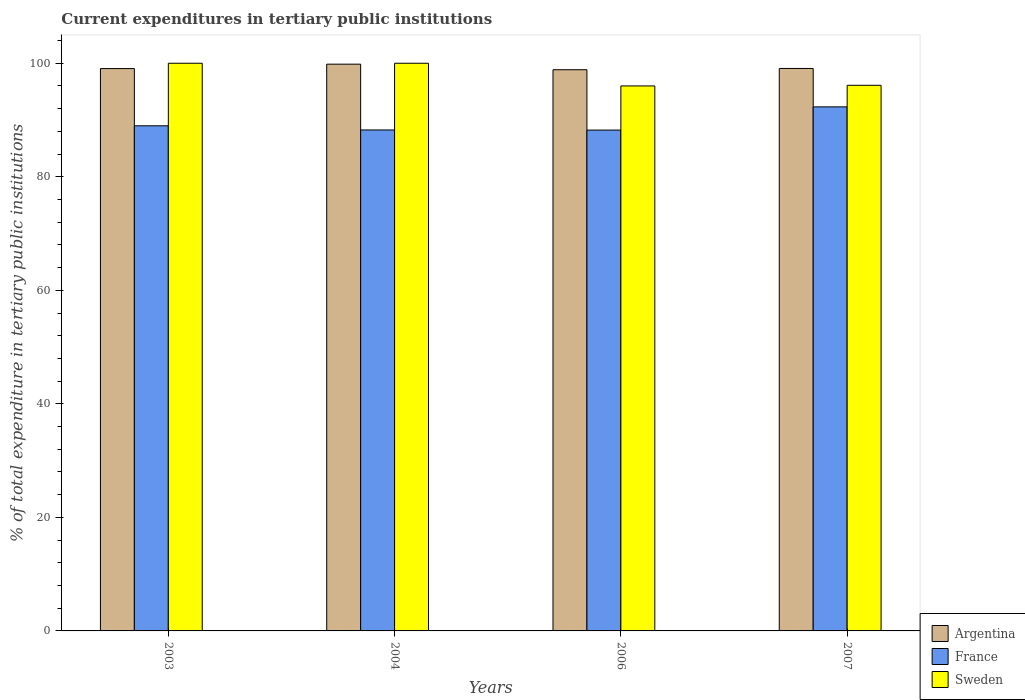How many different coloured bars are there?
Your response must be concise. 3. How many groups of bars are there?
Provide a succinct answer. 4. Are the number of bars per tick equal to the number of legend labels?
Keep it short and to the point. Yes. Are the number of bars on each tick of the X-axis equal?
Make the answer very short. Yes. What is the label of the 4th group of bars from the left?
Your answer should be compact. 2007. What is the current expenditures in tertiary public institutions in France in 2003?
Your answer should be compact. 88.98. Across all years, what is the maximum current expenditures in tertiary public institutions in France?
Your answer should be very brief. 92.32. Across all years, what is the minimum current expenditures in tertiary public institutions in Argentina?
Offer a terse response. 98.86. In which year was the current expenditures in tertiary public institutions in Sweden minimum?
Offer a very short reply. 2006. What is the total current expenditures in tertiary public institutions in France in the graph?
Your answer should be compact. 357.78. What is the difference between the current expenditures in tertiary public institutions in France in 2003 and that in 2004?
Offer a terse response. 0.73. What is the difference between the current expenditures in tertiary public institutions in Sweden in 2007 and the current expenditures in tertiary public institutions in Argentina in 2003?
Your response must be concise. -2.94. What is the average current expenditures in tertiary public institutions in Argentina per year?
Offer a very short reply. 99.21. In the year 2006, what is the difference between the current expenditures in tertiary public institutions in Sweden and current expenditures in tertiary public institutions in France?
Offer a terse response. 7.78. In how many years, is the current expenditures in tertiary public institutions in Argentina greater than 64 %?
Keep it short and to the point. 4. What is the ratio of the current expenditures in tertiary public institutions in Argentina in 2003 to that in 2007?
Make the answer very short. 1. Is the difference between the current expenditures in tertiary public institutions in Sweden in 2003 and 2004 greater than the difference between the current expenditures in tertiary public institutions in France in 2003 and 2004?
Ensure brevity in your answer.  No. What is the difference between the highest and the second highest current expenditures in tertiary public institutions in Argentina?
Give a very brief answer. 0.76. What is the difference between the highest and the lowest current expenditures in tertiary public institutions in France?
Provide a short and direct response. 4.09. What does the 1st bar from the right in 2003 represents?
Give a very brief answer. Sweden. Is it the case that in every year, the sum of the current expenditures in tertiary public institutions in France and current expenditures in tertiary public institutions in Argentina is greater than the current expenditures in tertiary public institutions in Sweden?
Your answer should be very brief. Yes. How many bars are there?
Provide a short and direct response. 12. Are all the bars in the graph horizontal?
Offer a terse response. No. Where does the legend appear in the graph?
Your response must be concise. Bottom right. How many legend labels are there?
Your answer should be compact. 3. How are the legend labels stacked?
Your response must be concise. Vertical. What is the title of the graph?
Your answer should be compact. Current expenditures in tertiary public institutions. Does "Ethiopia" appear as one of the legend labels in the graph?
Make the answer very short. No. What is the label or title of the X-axis?
Your answer should be compact. Years. What is the label or title of the Y-axis?
Your answer should be compact. % of total expenditure in tertiary public institutions. What is the % of total expenditure in tertiary public institutions in Argentina in 2003?
Give a very brief answer. 99.06. What is the % of total expenditure in tertiary public institutions of France in 2003?
Make the answer very short. 88.98. What is the % of total expenditure in tertiary public institutions of Sweden in 2003?
Offer a very short reply. 100. What is the % of total expenditure in tertiary public institutions of Argentina in 2004?
Make the answer very short. 99.84. What is the % of total expenditure in tertiary public institutions of France in 2004?
Give a very brief answer. 88.25. What is the % of total expenditure in tertiary public institutions in Sweden in 2004?
Provide a succinct answer. 100. What is the % of total expenditure in tertiary public institutions in Argentina in 2006?
Your answer should be very brief. 98.86. What is the % of total expenditure in tertiary public institutions in France in 2006?
Keep it short and to the point. 88.23. What is the % of total expenditure in tertiary public institutions of Sweden in 2006?
Give a very brief answer. 96.01. What is the % of total expenditure in tertiary public institutions in Argentina in 2007?
Give a very brief answer. 99.08. What is the % of total expenditure in tertiary public institutions of France in 2007?
Your answer should be compact. 92.32. What is the % of total expenditure in tertiary public institutions in Sweden in 2007?
Offer a very short reply. 96.12. Across all years, what is the maximum % of total expenditure in tertiary public institutions of Argentina?
Give a very brief answer. 99.84. Across all years, what is the maximum % of total expenditure in tertiary public institutions in France?
Ensure brevity in your answer.  92.32. Across all years, what is the maximum % of total expenditure in tertiary public institutions in Sweden?
Your response must be concise. 100. Across all years, what is the minimum % of total expenditure in tertiary public institutions in Argentina?
Your response must be concise. 98.86. Across all years, what is the minimum % of total expenditure in tertiary public institutions of France?
Keep it short and to the point. 88.23. Across all years, what is the minimum % of total expenditure in tertiary public institutions of Sweden?
Give a very brief answer. 96.01. What is the total % of total expenditure in tertiary public institutions in Argentina in the graph?
Give a very brief answer. 396.85. What is the total % of total expenditure in tertiary public institutions of France in the graph?
Your answer should be compact. 357.78. What is the total % of total expenditure in tertiary public institutions of Sweden in the graph?
Provide a succinct answer. 392.12. What is the difference between the % of total expenditure in tertiary public institutions of Argentina in 2003 and that in 2004?
Ensure brevity in your answer.  -0.78. What is the difference between the % of total expenditure in tertiary public institutions of France in 2003 and that in 2004?
Your answer should be compact. 0.73. What is the difference between the % of total expenditure in tertiary public institutions in Sweden in 2003 and that in 2004?
Your answer should be compact. 0. What is the difference between the % of total expenditure in tertiary public institutions in Argentina in 2003 and that in 2006?
Ensure brevity in your answer.  0.2. What is the difference between the % of total expenditure in tertiary public institutions in France in 2003 and that in 2006?
Your response must be concise. 0.75. What is the difference between the % of total expenditure in tertiary public institutions of Sweden in 2003 and that in 2006?
Your answer should be compact. 3.99. What is the difference between the % of total expenditure in tertiary public institutions in Argentina in 2003 and that in 2007?
Your answer should be compact. -0.02. What is the difference between the % of total expenditure in tertiary public institutions in France in 2003 and that in 2007?
Provide a short and direct response. -3.34. What is the difference between the % of total expenditure in tertiary public institutions in Sweden in 2003 and that in 2007?
Make the answer very short. 3.88. What is the difference between the % of total expenditure in tertiary public institutions of Argentina in 2004 and that in 2006?
Offer a terse response. 0.98. What is the difference between the % of total expenditure in tertiary public institutions of France in 2004 and that in 2006?
Make the answer very short. 0.02. What is the difference between the % of total expenditure in tertiary public institutions of Sweden in 2004 and that in 2006?
Your answer should be compact. 3.99. What is the difference between the % of total expenditure in tertiary public institutions of Argentina in 2004 and that in 2007?
Provide a succinct answer. 0.76. What is the difference between the % of total expenditure in tertiary public institutions of France in 2004 and that in 2007?
Provide a short and direct response. -4.07. What is the difference between the % of total expenditure in tertiary public institutions in Sweden in 2004 and that in 2007?
Provide a succinct answer. 3.88. What is the difference between the % of total expenditure in tertiary public institutions in Argentina in 2006 and that in 2007?
Provide a succinct answer. -0.22. What is the difference between the % of total expenditure in tertiary public institutions of France in 2006 and that in 2007?
Your answer should be compact. -4.09. What is the difference between the % of total expenditure in tertiary public institutions of Sweden in 2006 and that in 2007?
Make the answer very short. -0.11. What is the difference between the % of total expenditure in tertiary public institutions in Argentina in 2003 and the % of total expenditure in tertiary public institutions in France in 2004?
Your answer should be very brief. 10.81. What is the difference between the % of total expenditure in tertiary public institutions in Argentina in 2003 and the % of total expenditure in tertiary public institutions in Sweden in 2004?
Ensure brevity in your answer.  -0.94. What is the difference between the % of total expenditure in tertiary public institutions in France in 2003 and the % of total expenditure in tertiary public institutions in Sweden in 2004?
Provide a short and direct response. -11.02. What is the difference between the % of total expenditure in tertiary public institutions in Argentina in 2003 and the % of total expenditure in tertiary public institutions in France in 2006?
Ensure brevity in your answer.  10.83. What is the difference between the % of total expenditure in tertiary public institutions of Argentina in 2003 and the % of total expenditure in tertiary public institutions of Sweden in 2006?
Ensure brevity in your answer.  3.06. What is the difference between the % of total expenditure in tertiary public institutions in France in 2003 and the % of total expenditure in tertiary public institutions in Sweden in 2006?
Give a very brief answer. -7.03. What is the difference between the % of total expenditure in tertiary public institutions in Argentina in 2003 and the % of total expenditure in tertiary public institutions in France in 2007?
Give a very brief answer. 6.75. What is the difference between the % of total expenditure in tertiary public institutions in Argentina in 2003 and the % of total expenditure in tertiary public institutions in Sweden in 2007?
Provide a short and direct response. 2.94. What is the difference between the % of total expenditure in tertiary public institutions in France in 2003 and the % of total expenditure in tertiary public institutions in Sweden in 2007?
Ensure brevity in your answer.  -7.14. What is the difference between the % of total expenditure in tertiary public institutions in Argentina in 2004 and the % of total expenditure in tertiary public institutions in France in 2006?
Provide a succinct answer. 11.61. What is the difference between the % of total expenditure in tertiary public institutions of Argentina in 2004 and the % of total expenditure in tertiary public institutions of Sweden in 2006?
Make the answer very short. 3.83. What is the difference between the % of total expenditure in tertiary public institutions in France in 2004 and the % of total expenditure in tertiary public institutions in Sweden in 2006?
Make the answer very short. -7.76. What is the difference between the % of total expenditure in tertiary public institutions of Argentina in 2004 and the % of total expenditure in tertiary public institutions of France in 2007?
Keep it short and to the point. 7.52. What is the difference between the % of total expenditure in tertiary public institutions of Argentina in 2004 and the % of total expenditure in tertiary public institutions of Sweden in 2007?
Give a very brief answer. 3.72. What is the difference between the % of total expenditure in tertiary public institutions of France in 2004 and the % of total expenditure in tertiary public institutions of Sweden in 2007?
Offer a very short reply. -7.87. What is the difference between the % of total expenditure in tertiary public institutions in Argentina in 2006 and the % of total expenditure in tertiary public institutions in France in 2007?
Provide a succinct answer. 6.54. What is the difference between the % of total expenditure in tertiary public institutions in Argentina in 2006 and the % of total expenditure in tertiary public institutions in Sweden in 2007?
Your response must be concise. 2.74. What is the difference between the % of total expenditure in tertiary public institutions of France in 2006 and the % of total expenditure in tertiary public institutions of Sweden in 2007?
Make the answer very short. -7.89. What is the average % of total expenditure in tertiary public institutions in Argentina per year?
Keep it short and to the point. 99.21. What is the average % of total expenditure in tertiary public institutions of France per year?
Give a very brief answer. 89.44. What is the average % of total expenditure in tertiary public institutions of Sweden per year?
Ensure brevity in your answer.  98.03. In the year 2003, what is the difference between the % of total expenditure in tertiary public institutions of Argentina and % of total expenditure in tertiary public institutions of France?
Provide a succinct answer. 10.08. In the year 2003, what is the difference between the % of total expenditure in tertiary public institutions of Argentina and % of total expenditure in tertiary public institutions of Sweden?
Ensure brevity in your answer.  -0.94. In the year 2003, what is the difference between the % of total expenditure in tertiary public institutions in France and % of total expenditure in tertiary public institutions in Sweden?
Offer a terse response. -11.02. In the year 2004, what is the difference between the % of total expenditure in tertiary public institutions of Argentina and % of total expenditure in tertiary public institutions of France?
Provide a succinct answer. 11.59. In the year 2004, what is the difference between the % of total expenditure in tertiary public institutions in Argentina and % of total expenditure in tertiary public institutions in Sweden?
Provide a succinct answer. -0.16. In the year 2004, what is the difference between the % of total expenditure in tertiary public institutions of France and % of total expenditure in tertiary public institutions of Sweden?
Provide a succinct answer. -11.75. In the year 2006, what is the difference between the % of total expenditure in tertiary public institutions in Argentina and % of total expenditure in tertiary public institutions in France?
Your response must be concise. 10.63. In the year 2006, what is the difference between the % of total expenditure in tertiary public institutions of Argentina and % of total expenditure in tertiary public institutions of Sweden?
Your response must be concise. 2.86. In the year 2006, what is the difference between the % of total expenditure in tertiary public institutions of France and % of total expenditure in tertiary public institutions of Sweden?
Provide a succinct answer. -7.78. In the year 2007, what is the difference between the % of total expenditure in tertiary public institutions in Argentina and % of total expenditure in tertiary public institutions in France?
Provide a short and direct response. 6.77. In the year 2007, what is the difference between the % of total expenditure in tertiary public institutions of Argentina and % of total expenditure in tertiary public institutions of Sweden?
Your answer should be compact. 2.97. In the year 2007, what is the difference between the % of total expenditure in tertiary public institutions in France and % of total expenditure in tertiary public institutions in Sweden?
Your answer should be very brief. -3.8. What is the ratio of the % of total expenditure in tertiary public institutions in France in 2003 to that in 2004?
Provide a succinct answer. 1.01. What is the ratio of the % of total expenditure in tertiary public institutions of Sweden in 2003 to that in 2004?
Provide a short and direct response. 1. What is the ratio of the % of total expenditure in tertiary public institutions in France in 2003 to that in 2006?
Offer a very short reply. 1.01. What is the ratio of the % of total expenditure in tertiary public institutions in Sweden in 2003 to that in 2006?
Keep it short and to the point. 1.04. What is the ratio of the % of total expenditure in tertiary public institutions in France in 2003 to that in 2007?
Keep it short and to the point. 0.96. What is the ratio of the % of total expenditure in tertiary public institutions in Sweden in 2003 to that in 2007?
Your answer should be very brief. 1.04. What is the ratio of the % of total expenditure in tertiary public institutions in Argentina in 2004 to that in 2006?
Ensure brevity in your answer.  1.01. What is the ratio of the % of total expenditure in tertiary public institutions in France in 2004 to that in 2006?
Offer a terse response. 1. What is the ratio of the % of total expenditure in tertiary public institutions in Sweden in 2004 to that in 2006?
Provide a succinct answer. 1.04. What is the ratio of the % of total expenditure in tertiary public institutions in Argentina in 2004 to that in 2007?
Your response must be concise. 1.01. What is the ratio of the % of total expenditure in tertiary public institutions in France in 2004 to that in 2007?
Your answer should be very brief. 0.96. What is the ratio of the % of total expenditure in tertiary public institutions of Sweden in 2004 to that in 2007?
Make the answer very short. 1.04. What is the ratio of the % of total expenditure in tertiary public institutions in Argentina in 2006 to that in 2007?
Keep it short and to the point. 1. What is the ratio of the % of total expenditure in tertiary public institutions in France in 2006 to that in 2007?
Make the answer very short. 0.96. What is the difference between the highest and the second highest % of total expenditure in tertiary public institutions in Argentina?
Ensure brevity in your answer.  0.76. What is the difference between the highest and the second highest % of total expenditure in tertiary public institutions of France?
Provide a short and direct response. 3.34. What is the difference between the highest and the second highest % of total expenditure in tertiary public institutions in Sweden?
Keep it short and to the point. 0. What is the difference between the highest and the lowest % of total expenditure in tertiary public institutions of Argentina?
Keep it short and to the point. 0.98. What is the difference between the highest and the lowest % of total expenditure in tertiary public institutions of France?
Your answer should be compact. 4.09. What is the difference between the highest and the lowest % of total expenditure in tertiary public institutions of Sweden?
Keep it short and to the point. 3.99. 